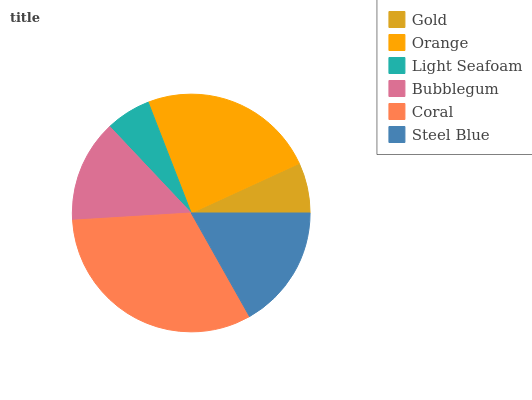Is Light Seafoam the minimum?
Answer yes or no. Yes. Is Coral the maximum?
Answer yes or no. Yes. Is Orange the minimum?
Answer yes or no. No. Is Orange the maximum?
Answer yes or no. No. Is Orange greater than Gold?
Answer yes or no. Yes. Is Gold less than Orange?
Answer yes or no. Yes. Is Gold greater than Orange?
Answer yes or no. No. Is Orange less than Gold?
Answer yes or no. No. Is Steel Blue the high median?
Answer yes or no. Yes. Is Bubblegum the low median?
Answer yes or no. Yes. Is Gold the high median?
Answer yes or no. No. Is Coral the low median?
Answer yes or no. No. 